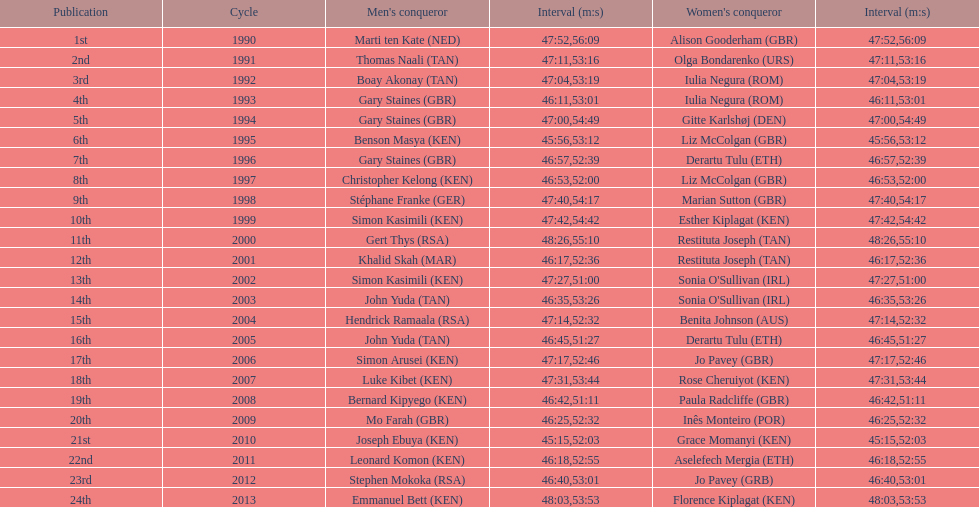How long did sonia o'sullivan take to finish in 2003? 53:26. 